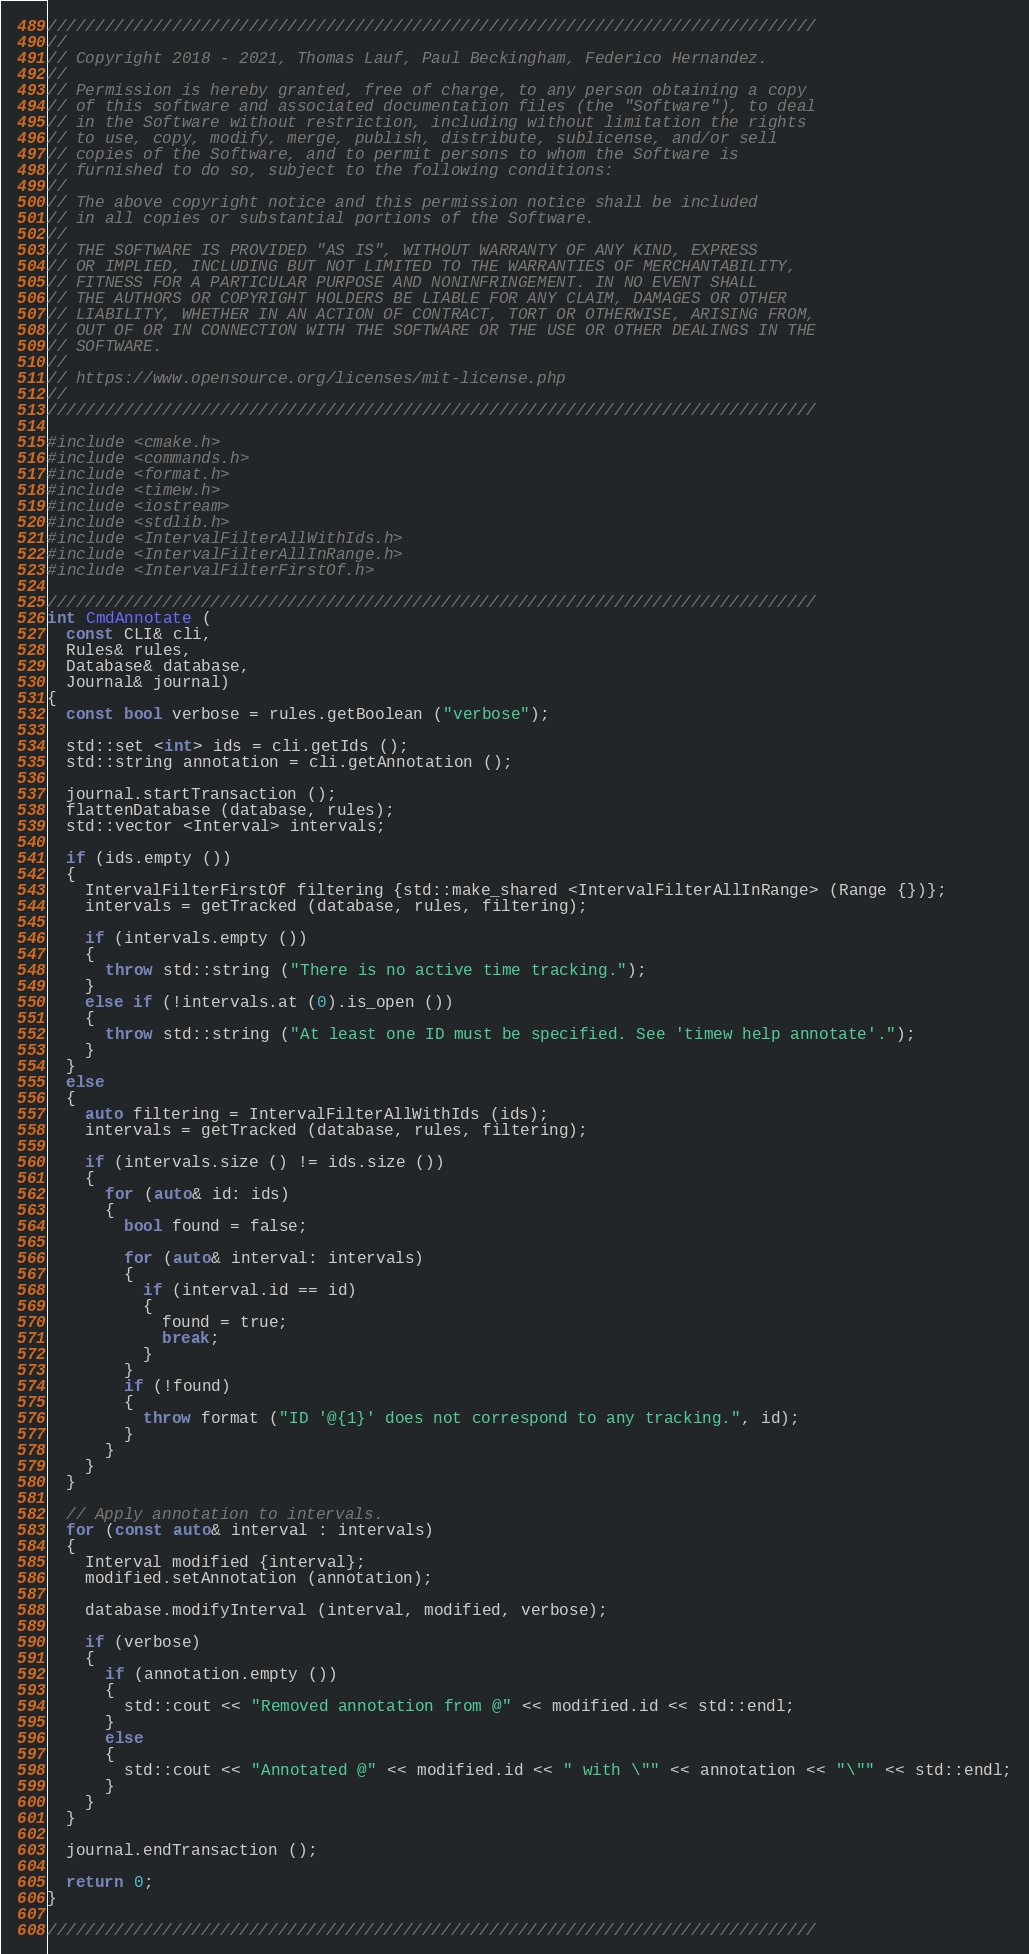Convert code to text. <code><loc_0><loc_0><loc_500><loc_500><_C++_>////////////////////////////////////////////////////////////////////////////////
//
// Copyright 2018 - 2021, Thomas Lauf, Paul Beckingham, Federico Hernandez.
//
// Permission is hereby granted, free of charge, to any person obtaining a copy
// of this software and associated documentation files (the "Software"), to deal
// in the Software without restriction, including without limitation the rights
// to use, copy, modify, merge, publish, distribute, sublicense, and/or sell
// copies of the Software, and to permit persons to whom the Software is
// furnished to do so, subject to the following conditions:
//
// The above copyright notice and this permission notice shall be included
// in all copies or substantial portions of the Software.
//
// THE SOFTWARE IS PROVIDED "AS IS", WITHOUT WARRANTY OF ANY KIND, EXPRESS
// OR IMPLIED, INCLUDING BUT NOT LIMITED TO THE WARRANTIES OF MERCHANTABILITY,
// FITNESS FOR A PARTICULAR PURPOSE AND NONINFRINGEMENT. IN NO EVENT SHALL
// THE AUTHORS OR COPYRIGHT HOLDERS BE LIABLE FOR ANY CLAIM, DAMAGES OR OTHER
// LIABILITY, WHETHER IN AN ACTION OF CONTRACT, TORT OR OTHERWISE, ARISING FROM,
// OUT OF OR IN CONNECTION WITH THE SOFTWARE OR THE USE OR OTHER DEALINGS IN THE
// SOFTWARE.
//
// https://www.opensource.org/licenses/mit-license.php
//
////////////////////////////////////////////////////////////////////////////////

#include <cmake.h>
#include <commands.h>
#include <format.h>
#include <timew.h>
#include <iostream>
#include <stdlib.h>
#include <IntervalFilterAllWithIds.h>
#include <IntervalFilterAllInRange.h>
#include <IntervalFilterFirstOf.h>

////////////////////////////////////////////////////////////////////////////////
int CmdAnnotate (
  const CLI& cli,
  Rules& rules,
  Database& database,
  Journal& journal)
{
  const bool verbose = rules.getBoolean ("verbose");

  std::set <int> ids = cli.getIds ();
  std::string annotation = cli.getAnnotation ();

  journal.startTransaction ();
  flattenDatabase (database, rules);
  std::vector <Interval> intervals;

  if (ids.empty ())
  {
    IntervalFilterFirstOf filtering {std::make_shared <IntervalFilterAllInRange> (Range {})};
    intervals = getTracked (database, rules, filtering);

    if (intervals.empty ())
    {
      throw std::string ("There is no active time tracking.");
    }
    else if (!intervals.at (0).is_open ())
    {
      throw std::string ("At least one ID must be specified. See 'timew help annotate'.");
    }
  }
  else
  {
    auto filtering = IntervalFilterAllWithIds (ids);
    intervals = getTracked (database, rules, filtering);

    if (intervals.size () != ids.size ())
    {
      for (auto& id: ids)
      {
        bool found = false;

        for (auto& interval: intervals)
        {
          if (interval.id == id)
          {
            found = true;
            break;
          }
        }
        if (!found)
        {
          throw format ("ID '@{1}' does not correspond to any tracking.", id);
        }
      }
    }
  }

  // Apply annotation to intervals.
  for (const auto& interval : intervals)
  {
    Interval modified {interval};
    modified.setAnnotation (annotation);

    database.modifyInterval (interval, modified, verbose);

    if (verbose)
    {
      if (annotation.empty ())
      {
        std::cout << "Removed annotation from @" << modified.id << std::endl;
      }
      else
      {
        std::cout << "Annotated @" << modified.id << " with \"" << annotation << "\"" << std::endl;
      }
    }
  }

  journal.endTransaction ();

  return 0;
}

////////////////////////////////////////////////////////////////////////////////
</code> 